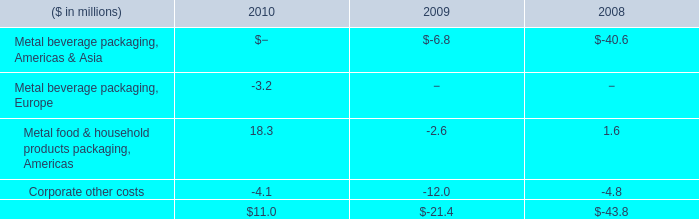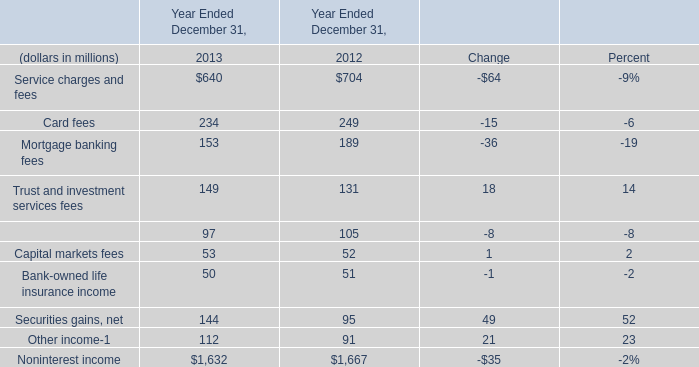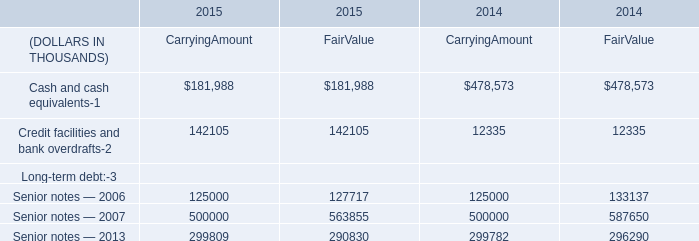What is the total amount of Cash and cash equivalents of 2015 CarryingAmount, and Noninterest income of Year Ended December 31, 2013 ? 
Computations: (181988.0 + 1632.0)
Answer: 183620.0. 